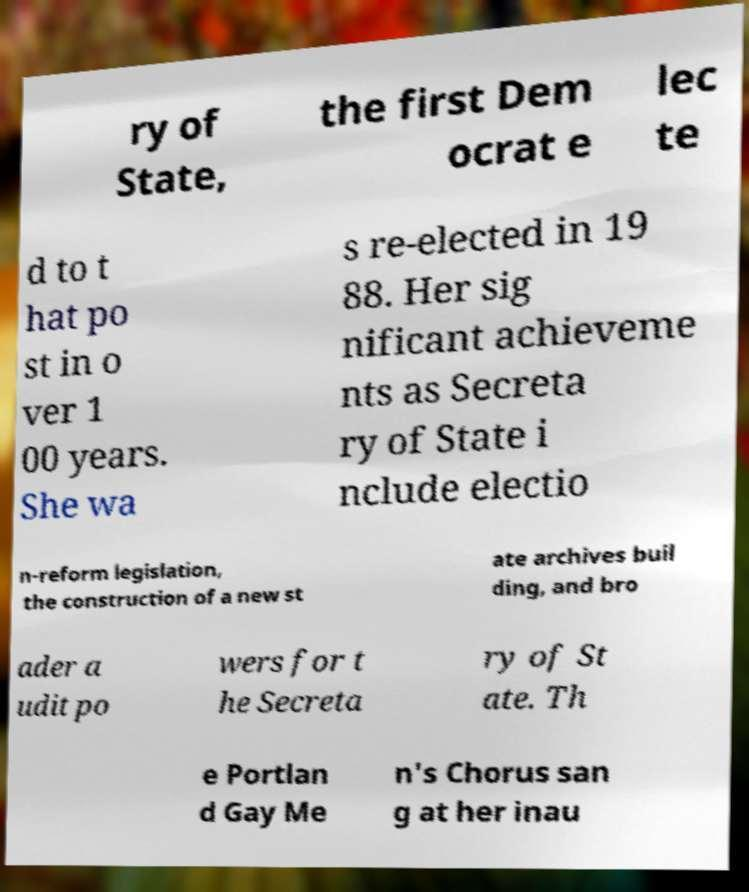Please identify and transcribe the text found in this image. ry of State, the first Dem ocrat e lec te d to t hat po st in o ver 1 00 years. She wa s re-elected in 19 88. Her sig nificant achieveme nts as Secreta ry of State i nclude electio n-reform legislation, the construction of a new st ate archives buil ding, and bro ader a udit po wers for t he Secreta ry of St ate. Th e Portlan d Gay Me n's Chorus san g at her inau 